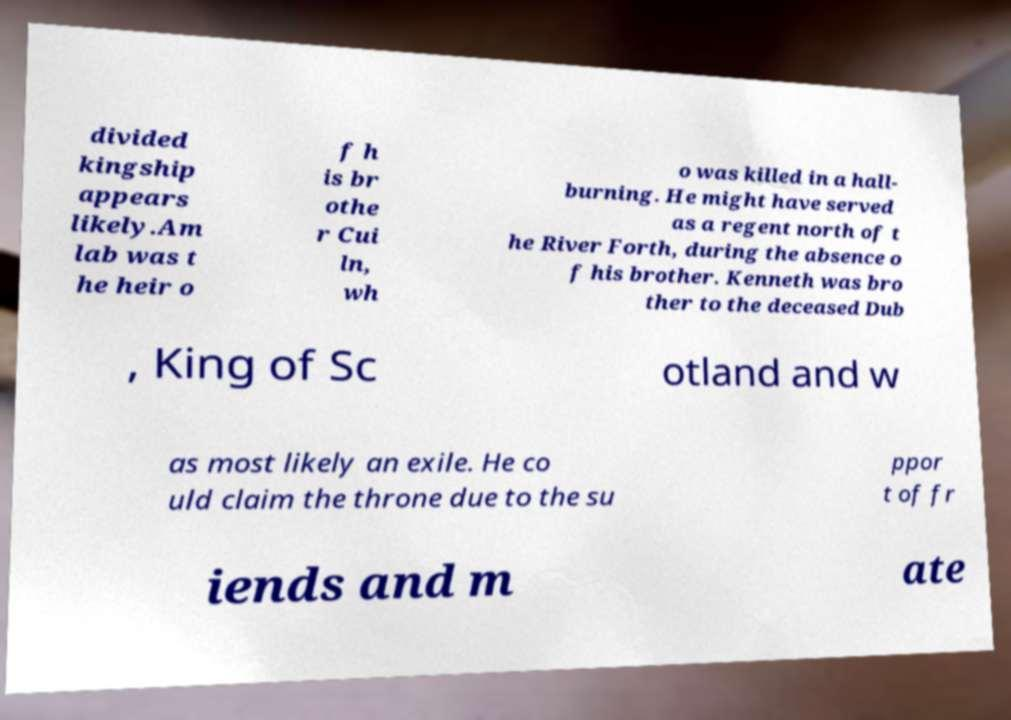Can you accurately transcribe the text from the provided image for me? divided kingship appears likely.Am lab was t he heir o f h is br othe r Cui ln, wh o was killed in a hall- burning. He might have served as a regent north of t he River Forth, during the absence o f his brother. Kenneth was bro ther to the deceased Dub , King of Sc otland and w as most likely an exile. He co uld claim the throne due to the su ppor t of fr iends and m ate 